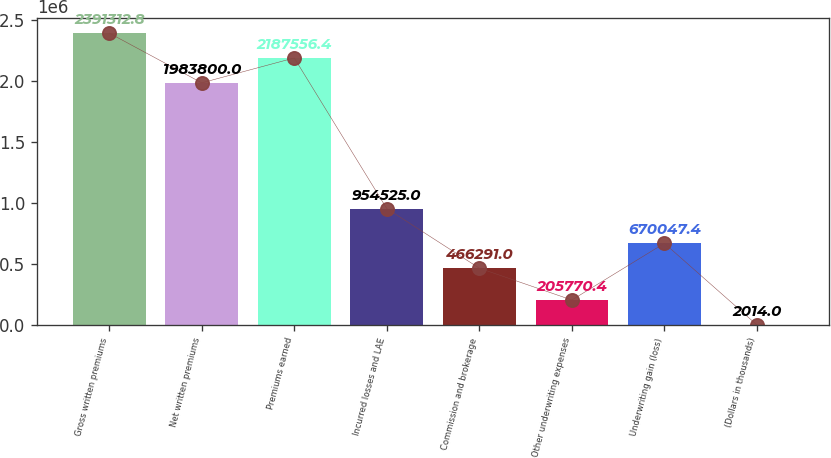Convert chart. <chart><loc_0><loc_0><loc_500><loc_500><bar_chart><fcel>Gross written premiums<fcel>Net written premiums<fcel>Premiums earned<fcel>Incurred losses and LAE<fcel>Commission and brokerage<fcel>Other underwriting expenses<fcel>Underwriting gain (loss)<fcel>(Dollars in thousands)<nl><fcel>2.39131e+06<fcel>1.9838e+06<fcel>2.18756e+06<fcel>954525<fcel>466291<fcel>205770<fcel>670047<fcel>2014<nl></chart> 